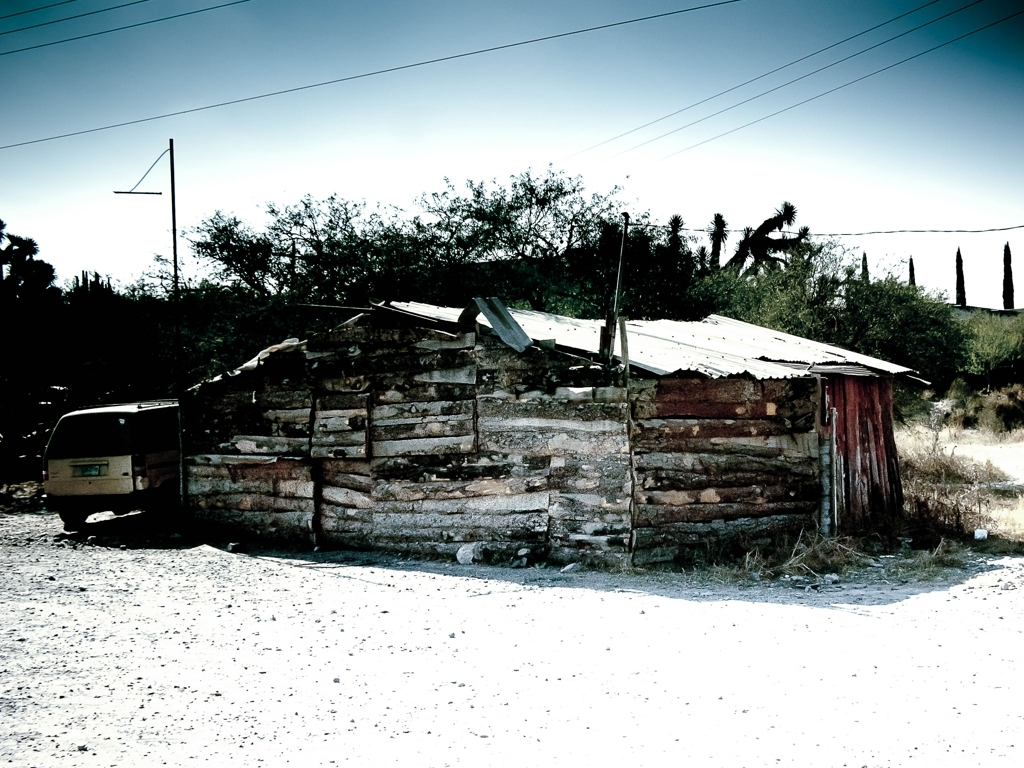What time of day does this photo appear to have been taken? The shadows are relatively short and the quality of the light suggests it could be late morning or early afternoon, given the brightness and the position of the shadows. 